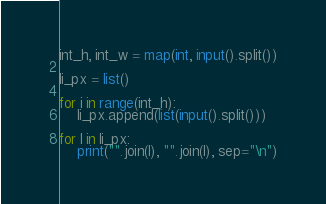<code> <loc_0><loc_0><loc_500><loc_500><_Python_>int_h, int_w = map(int, input().split())

li_px = list()

for i in range(int_h):
    li_px.append(list(input().split()))

for l in li_px:
    print("".join(l), "".join(l), sep="\n")</code> 